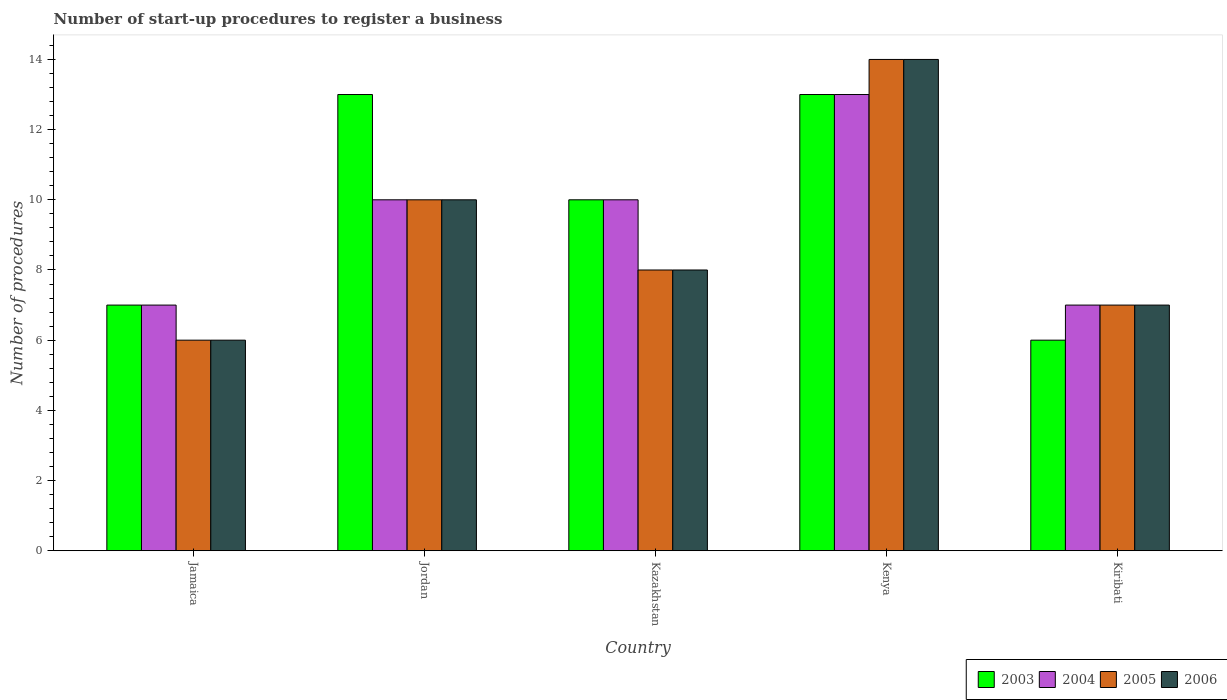How many different coloured bars are there?
Your response must be concise. 4. How many groups of bars are there?
Your response must be concise. 5. How many bars are there on the 3rd tick from the left?
Offer a terse response. 4. What is the label of the 4th group of bars from the left?
Your response must be concise. Kenya. In how many cases, is the number of bars for a given country not equal to the number of legend labels?
Provide a short and direct response. 0. Across all countries, what is the maximum number of procedures required to register a business in 2006?
Offer a terse response. 14. Across all countries, what is the minimum number of procedures required to register a business in 2005?
Keep it short and to the point. 6. In which country was the number of procedures required to register a business in 2006 maximum?
Provide a succinct answer. Kenya. In which country was the number of procedures required to register a business in 2004 minimum?
Your answer should be very brief. Jamaica. What is the total number of procedures required to register a business in 2004 in the graph?
Offer a terse response. 47. What is the difference between the number of procedures required to register a business in 2005 in Kenya and the number of procedures required to register a business in 2003 in Kiribati?
Your answer should be compact. 8. What is the difference between the number of procedures required to register a business of/in 2003 and number of procedures required to register a business of/in 2005 in Jordan?
Provide a short and direct response. 3. What is the ratio of the number of procedures required to register a business in 2003 in Kazakhstan to that in Kiribati?
Your answer should be very brief. 1.67. Is the number of procedures required to register a business in 2006 in Kazakhstan less than that in Kiribati?
Ensure brevity in your answer.  No. Is the difference between the number of procedures required to register a business in 2003 in Kazakhstan and Kiribati greater than the difference between the number of procedures required to register a business in 2005 in Kazakhstan and Kiribati?
Offer a terse response. Yes. Is the sum of the number of procedures required to register a business in 2006 in Jordan and Kiribati greater than the maximum number of procedures required to register a business in 2005 across all countries?
Ensure brevity in your answer.  Yes. What does the 3rd bar from the right in Kazakhstan represents?
Provide a short and direct response. 2004. How many bars are there?
Make the answer very short. 20. Are all the bars in the graph horizontal?
Your answer should be compact. No. Does the graph contain any zero values?
Give a very brief answer. No. How many legend labels are there?
Give a very brief answer. 4. What is the title of the graph?
Your answer should be very brief. Number of start-up procedures to register a business. What is the label or title of the X-axis?
Offer a very short reply. Country. What is the label or title of the Y-axis?
Provide a succinct answer. Number of procedures. What is the Number of procedures in 2004 in Jamaica?
Your answer should be compact. 7. What is the Number of procedures in 2003 in Kazakhstan?
Make the answer very short. 10. What is the Number of procedures of 2005 in Kazakhstan?
Provide a succinct answer. 8. What is the Number of procedures of 2006 in Kazakhstan?
Provide a short and direct response. 8. What is the Number of procedures of 2003 in Kenya?
Your response must be concise. 13. What is the Number of procedures in 2004 in Kenya?
Keep it short and to the point. 13. What is the Number of procedures in 2006 in Kenya?
Your response must be concise. 14. What is the Number of procedures in 2005 in Kiribati?
Your answer should be compact. 7. What is the Number of procedures of 2006 in Kiribati?
Your answer should be compact. 7. Across all countries, what is the maximum Number of procedures of 2005?
Ensure brevity in your answer.  14. Across all countries, what is the maximum Number of procedures of 2006?
Offer a terse response. 14. Across all countries, what is the minimum Number of procedures of 2003?
Offer a terse response. 6. Across all countries, what is the minimum Number of procedures of 2005?
Make the answer very short. 6. What is the total Number of procedures of 2003 in the graph?
Keep it short and to the point. 49. What is the difference between the Number of procedures of 2003 in Jamaica and that in Jordan?
Ensure brevity in your answer.  -6. What is the difference between the Number of procedures in 2006 in Jamaica and that in Jordan?
Offer a very short reply. -4. What is the difference between the Number of procedures of 2003 in Jamaica and that in Kazakhstan?
Keep it short and to the point. -3. What is the difference between the Number of procedures in 2004 in Jamaica and that in Kazakhstan?
Provide a short and direct response. -3. What is the difference between the Number of procedures in 2005 in Jamaica and that in Kazakhstan?
Your response must be concise. -2. What is the difference between the Number of procedures of 2006 in Jamaica and that in Kazakhstan?
Your answer should be compact. -2. What is the difference between the Number of procedures of 2004 in Jamaica and that in Kenya?
Ensure brevity in your answer.  -6. What is the difference between the Number of procedures in 2005 in Jamaica and that in Kenya?
Your response must be concise. -8. What is the difference between the Number of procedures of 2004 in Jamaica and that in Kiribati?
Your answer should be very brief. 0. What is the difference between the Number of procedures in 2005 in Jamaica and that in Kiribati?
Your answer should be compact. -1. What is the difference between the Number of procedures of 2004 in Jordan and that in Kazakhstan?
Your answer should be compact. 0. What is the difference between the Number of procedures of 2005 in Jordan and that in Kazakhstan?
Your answer should be very brief. 2. What is the difference between the Number of procedures of 2006 in Jordan and that in Kazakhstan?
Your answer should be very brief. 2. What is the difference between the Number of procedures in 2005 in Jordan and that in Kenya?
Keep it short and to the point. -4. What is the difference between the Number of procedures in 2004 in Jordan and that in Kiribati?
Offer a terse response. 3. What is the difference between the Number of procedures in 2003 in Kazakhstan and that in Kenya?
Your response must be concise. -3. What is the difference between the Number of procedures in 2005 in Kazakhstan and that in Kenya?
Offer a terse response. -6. What is the difference between the Number of procedures of 2006 in Kazakhstan and that in Kenya?
Give a very brief answer. -6. What is the difference between the Number of procedures in 2003 in Kazakhstan and that in Kiribati?
Provide a succinct answer. 4. What is the difference between the Number of procedures in 2005 in Kazakhstan and that in Kiribati?
Your answer should be very brief. 1. What is the difference between the Number of procedures of 2003 in Kenya and that in Kiribati?
Your response must be concise. 7. What is the difference between the Number of procedures of 2005 in Kenya and that in Kiribati?
Offer a terse response. 7. What is the difference between the Number of procedures of 2006 in Kenya and that in Kiribati?
Offer a very short reply. 7. What is the difference between the Number of procedures in 2003 in Jamaica and the Number of procedures in 2004 in Jordan?
Your answer should be compact. -3. What is the difference between the Number of procedures of 2005 in Jamaica and the Number of procedures of 2006 in Jordan?
Make the answer very short. -4. What is the difference between the Number of procedures in 2003 in Jamaica and the Number of procedures in 2004 in Kazakhstan?
Provide a short and direct response. -3. What is the difference between the Number of procedures in 2003 in Jamaica and the Number of procedures in 2005 in Kazakhstan?
Your answer should be compact. -1. What is the difference between the Number of procedures of 2004 in Jamaica and the Number of procedures of 2005 in Kazakhstan?
Ensure brevity in your answer.  -1. What is the difference between the Number of procedures of 2004 in Jamaica and the Number of procedures of 2006 in Kazakhstan?
Your answer should be compact. -1. What is the difference between the Number of procedures of 2005 in Jamaica and the Number of procedures of 2006 in Kazakhstan?
Provide a succinct answer. -2. What is the difference between the Number of procedures in 2003 in Jamaica and the Number of procedures in 2005 in Kenya?
Keep it short and to the point. -7. What is the difference between the Number of procedures of 2003 in Jamaica and the Number of procedures of 2006 in Kenya?
Your answer should be very brief. -7. What is the difference between the Number of procedures in 2003 in Jamaica and the Number of procedures in 2004 in Kiribati?
Your answer should be very brief. 0. What is the difference between the Number of procedures in 2003 in Jamaica and the Number of procedures in 2005 in Kiribati?
Provide a short and direct response. 0. What is the difference between the Number of procedures of 2004 in Jamaica and the Number of procedures of 2006 in Kiribati?
Make the answer very short. 0. What is the difference between the Number of procedures of 2005 in Jamaica and the Number of procedures of 2006 in Kiribati?
Keep it short and to the point. -1. What is the difference between the Number of procedures of 2003 in Jordan and the Number of procedures of 2004 in Kazakhstan?
Offer a very short reply. 3. What is the difference between the Number of procedures of 2003 in Jordan and the Number of procedures of 2005 in Kazakhstan?
Provide a succinct answer. 5. What is the difference between the Number of procedures in 2003 in Jordan and the Number of procedures in 2006 in Kazakhstan?
Ensure brevity in your answer.  5. What is the difference between the Number of procedures in 2004 in Jordan and the Number of procedures in 2006 in Kazakhstan?
Your answer should be compact. 2. What is the difference between the Number of procedures in 2003 in Jordan and the Number of procedures in 2004 in Kenya?
Make the answer very short. 0. What is the difference between the Number of procedures of 2003 in Jordan and the Number of procedures of 2005 in Kenya?
Keep it short and to the point. -1. What is the difference between the Number of procedures of 2005 in Jordan and the Number of procedures of 2006 in Kenya?
Offer a terse response. -4. What is the difference between the Number of procedures of 2003 in Jordan and the Number of procedures of 2004 in Kiribati?
Your answer should be compact. 6. What is the difference between the Number of procedures of 2003 in Jordan and the Number of procedures of 2005 in Kiribati?
Keep it short and to the point. 6. What is the difference between the Number of procedures of 2003 in Jordan and the Number of procedures of 2006 in Kiribati?
Keep it short and to the point. 6. What is the difference between the Number of procedures of 2004 in Jordan and the Number of procedures of 2005 in Kiribati?
Keep it short and to the point. 3. What is the difference between the Number of procedures in 2004 in Jordan and the Number of procedures in 2006 in Kiribati?
Provide a short and direct response. 3. What is the difference between the Number of procedures of 2003 in Kazakhstan and the Number of procedures of 2006 in Kenya?
Provide a succinct answer. -4. What is the difference between the Number of procedures of 2004 in Kazakhstan and the Number of procedures of 2005 in Kenya?
Your response must be concise. -4. What is the difference between the Number of procedures in 2005 in Kazakhstan and the Number of procedures in 2006 in Kenya?
Provide a succinct answer. -6. What is the difference between the Number of procedures of 2003 in Kazakhstan and the Number of procedures of 2004 in Kiribati?
Offer a very short reply. 3. What is the difference between the Number of procedures in 2003 in Kazakhstan and the Number of procedures in 2005 in Kiribati?
Keep it short and to the point. 3. What is the difference between the Number of procedures in 2003 in Kazakhstan and the Number of procedures in 2006 in Kiribati?
Give a very brief answer. 3. What is the difference between the Number of procedures of 2004 in Kazakhstan and the Number of procedures of 2006 in Kiribati?
Your answer should be compact. 3. What is the difference between the Number of procedures in 2005 in Kazakhstan and the Number of procedures in 2006 in Kiribati?
Provide a short and direct response. 1. What is the difference between the Number of procedures of 2003 in Kenya and the Number of procedures of 2004 in Kiribati?
Your response must be concise. 6. What is the difference between the Number of procedures in 2003 in Kenya and the Number of procedures in 2005 in Kiribati?
Keep it short and to the point. 6. What is the difference between the Number of procedures in 2004 in Kenya and the Number of procedures in 2005 in Kiribati?
Give a very brief answer. 6. What is the difference between the Number of procedures of 2005 in Kenya and the Number of procedures of 2006 in Kiribati?
Give a very brief answer. 7. What is the difference between the Number of procedures in 2004 and Number of procedures in 2005 in Jamaica?
Keep it short and to the point. 1. What is the difference between the Number of procedures of 2004 and Number of procedures of 2006 in Jamaica?
Provide a succinct answer. 1. What is the difference between the Number of procedures in 2003 and Number of procedures in 2005 in Jordan?
Make the answer very short. 3. What is the difference between the Number of procedures in 2004 and Number of procedures in 2005 in Jordan?
Offer a terse response. 0. What is the difference between the Number of procedures of 2004 and Number of procedures of 2006 in Jordan?
Your answer should be compact. 0. What is the difference between the Number of procedures of 2005 and Number of procedures of 2006 in Jordan?
Your answer should be very brief. 0. What is the difference between the Number of procedures of 2003 and Number of procedures of 2004 in Kazakhstan?
Offer a terse response. 0. What is the difference between the Number of procedures of 2003 and Number of procedures of 2005 in Kazakhstan?
Give a very brief answer. 2. What is the difference between the Number of procedures in 2003 and Number of procedures in 2004 in Kenya?
Your answer should be very brief. 0. What is the difference between the Number of procedures in 2003 and Number of procedures in 2005 in Kenya?
Provide a short and direct response. -1. What is the difference between the Number of procedures in 2003 and Number of procedures in 2006 in Kenya?
Your response must be concise. -1. What is the ratio of the Number of procedures of 2003 in Jamaica to that in Jordan?
Offer a very short reply. 0.54. What is the ratio of the Number of procedures of 2004 in Jamaica to that in Jordan?
Provide a succinct answer. 0.7. What is the ratio of the Number of procedures in 2005 in Jamaica to that in Jordan?
Your answer should be very brief. 0.6. What is the ratio of the Number of procedures of 2004 in Jamaica to that in Kazakhstan?
Provide a succinct answer. 0.7. What is the ratio of the Number of procedures of 2005 in Jamaica to that in Kazakhstan?
Offer a terse response. 0.75. What is the ratio of the Number of procedures of 2006 in Jamaica to that in Kazakhstan?
Your answer should be compact. 0.75. What is the ratio of the Number of procedures of 2003 in Jamaica to that in Kenya?
Give a very brief answer. 0.54. What is the ratio of the Number of procedures of 2004 in Jamaica to that in Kenya?
Your answer should be compact. 0.54. What is the ratio of the Number of procedures in 2005 in Jamaica to that in Kenya?
Keep it short and to the point. 0.43. What is the ratio of the Number of procedures in 2006 in Jamaica to that in Kenya?
Provide a short and direct response. 0.43. What is the ratio of the Number of procedures in 2004 in Jamaica to that in Kiribati?
Offer a very short reply. 1. What is the ratio of the Number of procedures in 2005 in Jamaica to that in Kiribati?
Offer a terse response. 0.86. What is the ratio of the Number of procedures in 2005 in Jordan to that in Kazakhstan?
Your response must be concise. 1.25. What is the ratio of the Number of procedures of 2003 in Jordan to that in Kenya?
Your response must be concise. 1. What is the ratio of the Number of procedures of 2004 in Jordan to that in Kenya?
Provide a succinct answer. 0.77. What is the ratio of the Number of procedures of 2003 in Jordan to that in Kiribati?
Provide a short and direct response. 2.17. What is the ratio of the Number of procedures of 2004 in Jordan to that in Kiribati?
Your answer should be compact. 1.43. What is the ratio of the Number of procedures in 2005 in Jordan to that in Kiribati?
Offer a very short reply. 1.43. What is the ratio of the Number of procedures in 2006 in Jordan to that in Kiribati?
Give a very brief answer. 1.43. What is the ratio of the Number of procedures of 2003 in Kazakhstan to that in Kenya?
Make the answer very short. 0.77. What is the ratio of the Number of procedures in 2004 in Kazakhstan to that in Kenya?
Ensure brevity in your answer.  0.77. What is the ratio of the Number of procedures in 2005 in Kazakhstan to that in Kenya?
Make the answer very short. 0.57. What is the ratio of the Number of procedures of 2006 in Kazakhstan to that in Kenya?
Keep it short and to the point. 0.57. What is the ratio of the Number of procedures of 2003 in Kazakhstan to that in Kiribati?
Provide a succinct answer. 1.67. What is the ratio of the Number of procedures of 2004 in Kazakhstan to that in Kiribati?
Your answer should be very brief. 1.43. What is the ratio of the Number of procedures in 2006 in Kazakhstan to that in Kiribati?
Your answer should be compact. 1.14. What is the ratio of the Number of procedures in 2003 in Kenya to that in Kiribati?
Ensure brevity in your answer.  2.17. What is the ratio of the Number of procedures in 2004 in Kenya to that in Kiribati?
Your answer should be very brief. 1.86. What is the difference between the highest and the second highest Number of procedures in 2003?
Your answer should be compact. 0. What is the difference between the highest and the second highest Number of procedures in 2004?
Provide a short and direct response. 3. What is the difference between the highest and the second highest Number of procedures in 2005?
Your response must be concise. 4. What is the difference between the highest and the lowest Number of procedures in 2003?
Ensure brevity in your answer.  7. What is the difference between the highest and the lowest Number of procedures in 2006?
Your response must be concise. 8. 